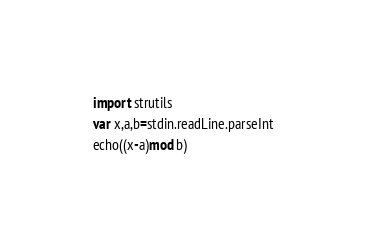Convert code to text. <code><loc_0><loc_0><loc_500><loc_500><_Nim_>import strutils
var x,a,b=stdin.readLine.parseInt
echo((x-a)mod b)</code> 